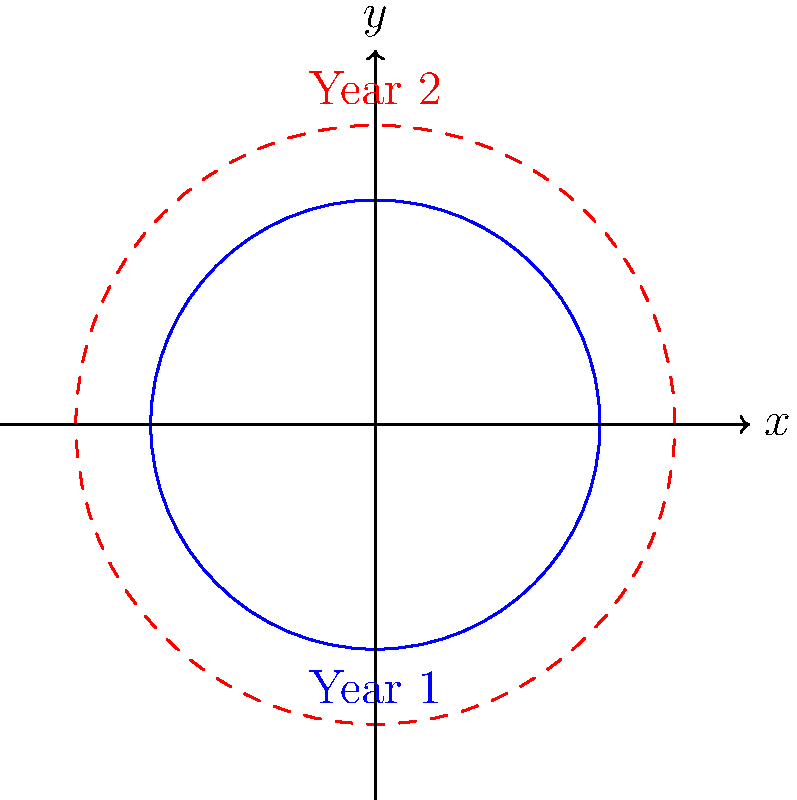A financial literacy program's coverage area is represented by a circular region. In the first year, the program reaches a circular area with a radius of 30 km. If the program expands its coverage radius by 10 km in the second year, what is the increase in the perimeter of the coverage area? Round your answer to the nearest kilometer. Let's approach this step-by-step:

1) First, let's recall the formula for the perimeter (circumference) of a circle:
   $P = 2\pi r$, where $r$ is the radius

2) For Year 1:
   Radius $r_1 = 30$ km
   Perimeter $P_1 = 2\pi r_1 = 2\pi(30) = 60\pi$ km

3) For Year 2:
   Radius $r_2 = 30 + 10 = 40$ km
   Perimeter $P_2 = 2\pi r_2 = 2\pi(40) = 80\pi$ km

4) The increase in perimeter is:
   $\Delta P = P_2 - P_1 = 80\pi - 60\pi = 20\pi$ km

5) Converting to a numerical value:
   $20\pi \approx 62.83$ km

6) Rounding to the nearest kilometer:
   $62.83$ km rounds to 63 km

Therefore, the increase in the perimeter of the coverage area is approximately 63 km.
Answer: 63 km 